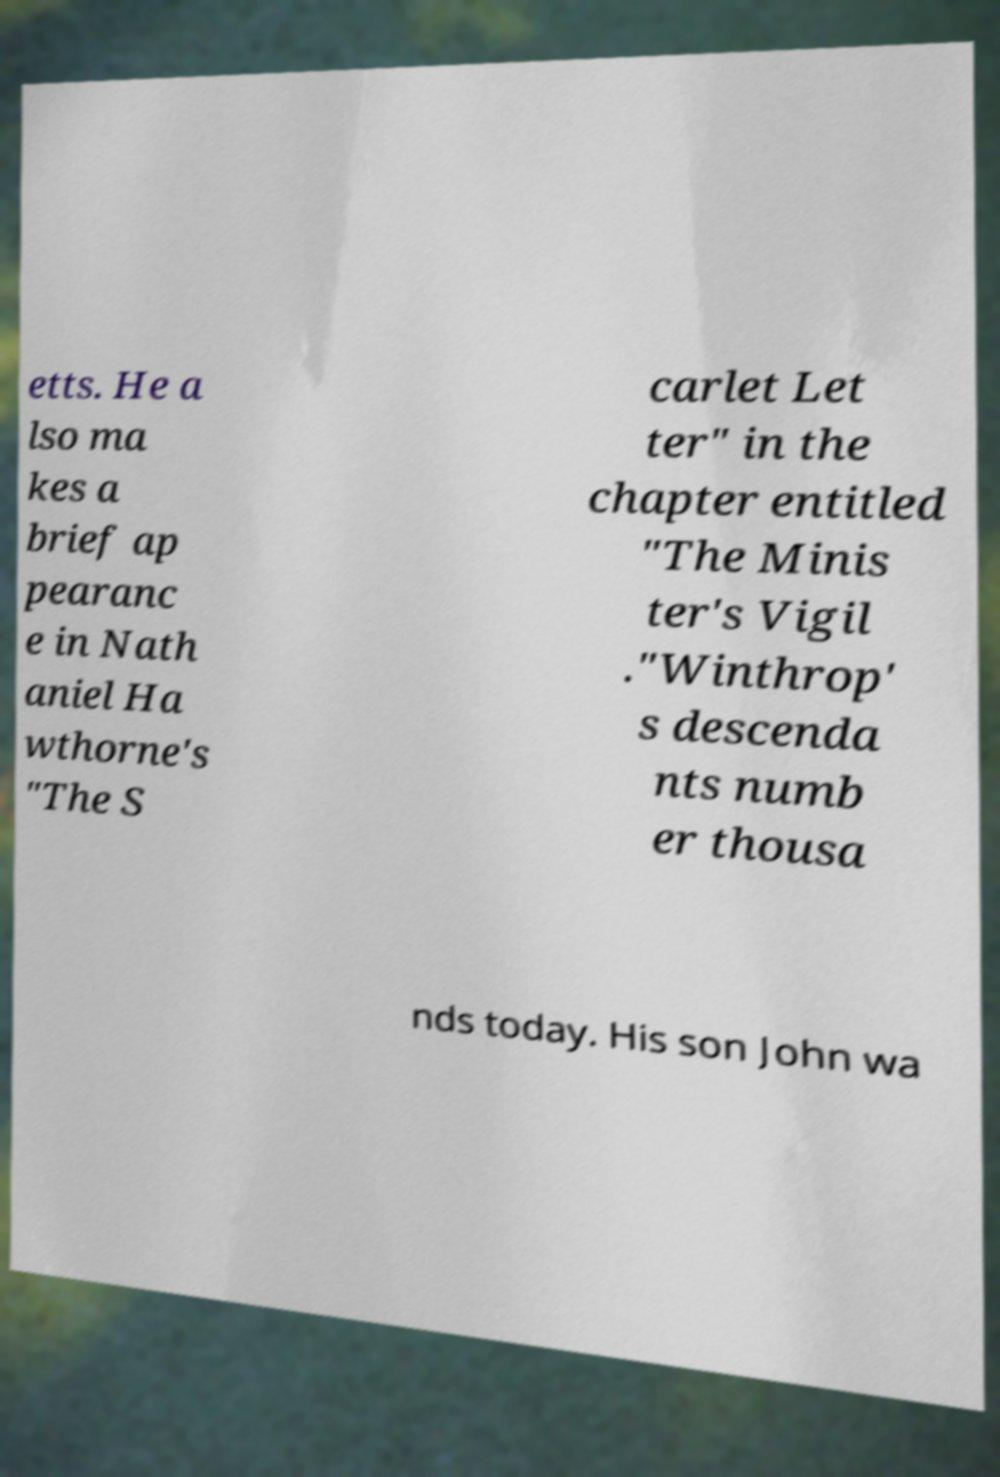Please identify and transcribe the text found in this image. etts. He a lso ma kes a brief ap pearanc e in Nath aniel Ha wthorne's "The S carlet Let ter" in the chapter entitled "The Minis ter's Vigil ."Winthrop' s descenda nts numb er thousa nds today. His son John wa 